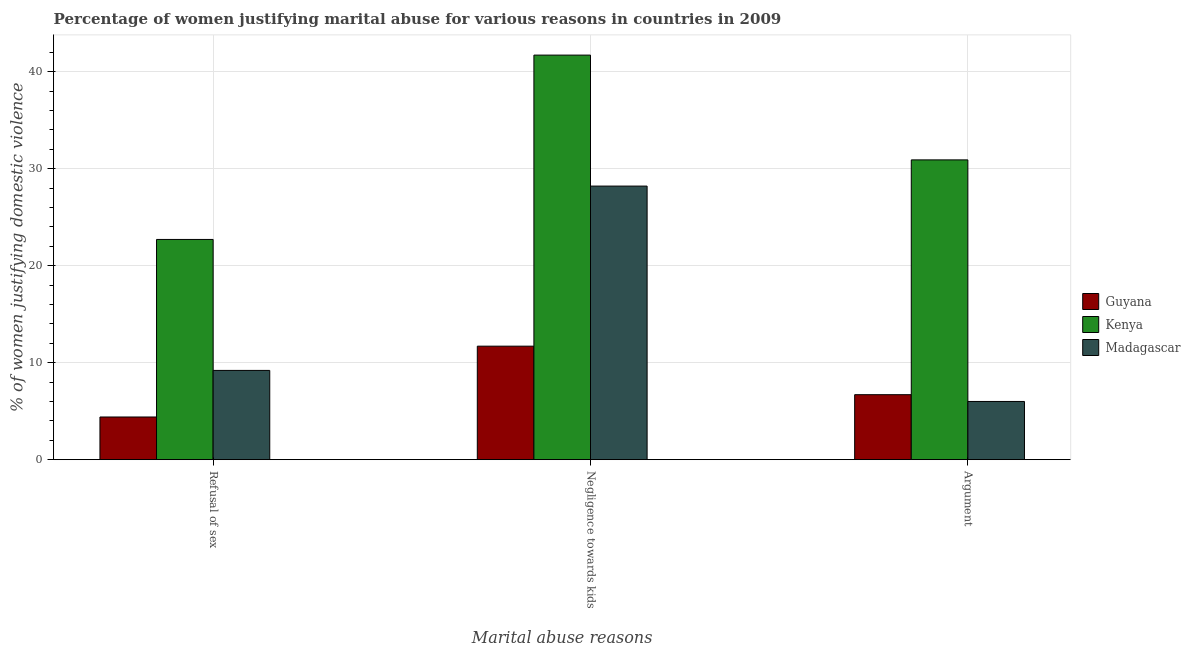How many groups of bars are there?
Offer a terse response. 3. How many bars are there on the 3rd tick from the right?
Make the answer very short. 3. What is the label of the 1st group of bars from the left?
Provide a succinct answer. Refusal of sex. Across all countries, what is the maximum percentage of women justifying domestic violence due to negligence towards kids?
Keep it short and to the point. 41.7. In which country was the percentage of women justifying domestic violence due to arguments maximum?
Provide a succinct answer. Kenya. In which country was the percentage of women justifying domestic violence due to arguments minimum?
Offer a terse response. Madagascar. What is the total percentage of women justifying domestic violence due to arguments in the graph?
Your answer should be compact. 43.6. What is the difference between the percentage of women justifying domestic violence due to negligence towards kids in Guyana and that in Madagascar?
Ensure brevity in your answer.  -16.5. What is the difference between the percentage of women justifying domestic violence due to arguments in Guyana and the percentage of women justifying domestic violence due to negligence towards kids in Kenya?
Offer a terse response. -35. What is the average percentage of women justifying domestic violence due to arguments per country?
Make the answer very short. 14.53. What is the difference between the percentage of women justifying domestic violence due to arguments and percentage of women justifying domestic violence due to negligence towards kids in Madagascar?
Offer a very short reply. -22.2. In how many countries, is the percentage of women justifying domestic violence due to arguments greater than 22 %?
Provide a succinct answer. 1. What is the ratio of the percentage of women justifying domestic violence due to arguments in Guyana to that in Kenya?
Give a very brief answer. 0.22. Is the percentage of women justifying domestic violence due to negligence towards kids in Guyana less than that in Madagascar?
Give a very brief answer. Yes. Is the difference between the percentage of women justifying domestic violence due to negligence towards kids in Guyana and Madagascar greater than the difference between the percentage of women justifying domestic violence due to arguments in Guyana and Madagascar?
Your response must be concise. No. What is the difference between the highest and the second highest percentage of women justifying domestic violence due to negligence towards kids?
Offer a terse response. 13.5. What is the difference between the highest and the lowest percentage of women justifying domestic violence due to negligence towards kids?
Your answer should be compact. 30. What does the 3rd bar from the left in Negligence towards kids represents?
Your answer should be compact. Madagascar. What does the 1st bar from the right in Argument represents?
Offer a terse response. Madagascar. Is it the case that in every country, the sum of the percentage of women justifying domestic violence due to refusal of sex and percentage of women justifying domestic violence due to negligence towards kids is greater than the percentage of women justifying domestic violence due to arguments?
Ensure brevity in your answer.  Yes. How many bars are there?
Make the answer very short. 9. Are all the bars in the graph horizontal?
Your response must be concise. No. What is the difference between two consecutive major ticks on the Y-axis?
Ensure brevity in your answer.  10. Are the values on the major ticks of Y-axis written in scientific E-notation?
Offer a very short reply. No. Does the graph contain any zero values?
Provide a short and direct response. No. Where does the legend appear in the graph?
Your answer should be compact. Center right. How are the legend labels stacked?
Offer a terse response. Vertical. What is the title of the graph?
Make the answer very short. Percentage of women justifying marital abuse for various reasons in countries in 2009. What is the label or title of the X-axis?
Provide a succinct answer. Marital abuse reasons. What is the label or title of the Y-axis?
Provide a short and direct response. % of women justifying domestic violence. What is the % of women justifying domestic violence of Guyana in Refusal of sex?
Make the answer very short. 4.4. What is the % of women justifying domestic violence of Kenya in Refusal of sex?
Provide a succinct answer. 22.7. What is the % of women justifying domestic violence in Kenya in Negligence towards kids?
Your response must be concise. 41.7. What is the % of women justifying domestic violence in Madagascar in Negligence towards kids?
Offer a terse response. 28.2. What is the % of women justifying domestic violence in Kenya in Argument?
Provide a succinct answer. 30.9. Across all Marital abuse reasons, what is the maximum % of women justifying domestic violence of Kenya?
Your response must be concise. 41.7. Across all Marital abuse reasons, what is the maximum % of women justifying domestic violence in Madagascar?
Your response must be concise. 28.2. Across all Marital abuse reasons, what is the minimum % of women justifying domestic violence of Kenya?
Offer a very short reply. 22.7. What is the total % of women justifying domestic violence in Guyana in the graph?
Your answer should be very brief. 22.8. What is the total % of women justifying domestic violence in Kenya in the graph?
Your response must be concise. 95.3. What is the total % of women justifying domestic violence of Madagascar in the graph?
Make the answer very short. 43.4. What is the difference between the % of women justifying domestic violence of Guyana in Refusal of sex and that in Negligence towards kids?
Offer a very short reply. -7.3. What is the difference between the % of women justifying domestic violence in Kenya in Refusal of sex and that in Negligence towards kids?
Make the answer very short. -19. What is the difference between the % of women justifying domestic violence of Guyana in Negligence towards kids and that in Argument?
Offer a terse response. 5. What is the difference between the % of women justifying domestic violence of Kenya in Negligence towards kids and that in Argument?
Offer a very short reply. 10.8. What is the difference between the % of women justifying domestic violence in Guyana in Refusal of sex and the % of women justifying domestic violence in Kenya in Negligence towards kids?
Offer a terse response. -37.3. What is the difference between the % of women justifying domestic violence in Guyana in Refusal of sex and the % of women justifying domestic violence in Madagascar in Negligence towards kids?
Make the answer very short. -23.8. What is the difference between the % of women justifying domestic violence in Kenya in Refusal of sex and the % of women justifying domestic violence in Madagascar in Negligence towards kids?
Offer a very short reply. -5.5. What is the difference between the % of women justifying domestic violence of Guyana in Refusal of sex and the % of women justifying domestic violence of Kenya in Argument?
Make the answer very short. -26.5. What is the difference between the % of women justifying domestic violence in Guyana in Refusal of sex and the % of women justifying domestic violence in Madagascar in Argument?
Give a very brief answer. -1.6. What is the difference between the % of women justifying domestic violence in Kenya in Refusal of sex and the % of women justifying domestic violence in Madagascar in Argument?
Provide a short and direct response. 16.7. What is the difference between the % of women justifying domestic violence in Guyana in Negligence towards kids and the % of women justifying domestic violence in Kenya in Argument?
Provide a short and direct response. -19.2. What is the difference between the % of women justifying domestic violence in Kenya in Negligence towards kids and the % of women justifying domestic violence in Madagascar in Argument?
Offer a terse response. 35.7. What is the average % of women justifying domestic violence in Guyana per Marital abuse reasons?
Provide a short and direct response. 7.6. What is the average % of women justifying domestic violence of Kenya per Marital abuse reasons?
Your answer should be compact. 31.77. What is the average % of women justifying domestic violence in Madagascar per Marital abuse reasons?
Make the answer very short. 14.47. What is the difference between the % of women justifying domestic violence of Guyana and % of women justifying domestic violence of Kenya in Refusal of sex?
Give a very brief answer. -18.3. What is the difference between the % of women justifying domestic violence of Guyana and % of women justifying domestic violence of Madagascar in Refusal of sex?
Give a very brief answer. -4.8. What is the difference between the % of women justifying domestic violence of Kenya and % of women justifying domestic violence of Madagascar in Refusal of sex?
Your answer should be compact. 13.5. What is the difference between the % of women justifying domestic violence in Guyana and % of women justifying domestic violence in Madagascar in Negligence towards kids?
Provide a succinct answer. -16.5. What is the difference between the % of women justifying domestic violence of Guyana and % of women justifying domestic violence of Kenya in Argument?
Provide a succinct answer. -24.2. What is the difference between the % of women justifying domestic violence in Guyana and % of women justifying domestic violence in Madagascar in Argument?
Keep it short and to the point. 0.7. What is the difference between the % of women justifying domestic violence in Kenya and % of women justifying domestic violence in Madagascar in Argument?
Make the answer very short. 24.9. What is the ratio of the % of women justifying domestic violence of Guyana in Refusal of sex to that in Negligence towards kids?
Your response must be concise. 0.38. What is the ratio of the % of women justifying domestic violence in Kenya in Refusal of sex to that in Negligence towards kids?
Your answer should be very brief. 0.54. What is the ratio of the % of women justifying domestic violence of Madagascar in Refusal of sex to that in Negligence towards kids?
Ensure brevity in your answer.  0.33. What is the ratio of the % of women justifying domestic violence in Guyana in Refusal of sex to that in Argument?
Your answer should be very brief. 0.66. What is the ratio of the % of women justifying domestic violence of Kenya in Refusal of sex to that in Argument?
Make the answer very short. 0.73. What is the ratio of the % of women justifying domestic violence of Madagascar in Refusal of sex to that in Argument?
Your answer should be compact. 1.53. What is the ratio of the % of women justifying domestic violence in Guyana in Negligence towards kids to that in Argument?
Provide a short and direct response. 1.75. What is the ratio of the % of women justifying domestic violence in Kenya in Negligence towards kids to that in Argument?
Keep it short and to the point. 1.35. What is the ratio of the % of women justifying domestic violence in Madagascar in Negligence towards kids to that in Argument?
Provide a short and direct response. 4.7. What is the difference between the highest and the second highest % of women justifying domestic violence of Guyana?
Offer a terse response. 5. What is the difference between the highest and the second highest % of women justifying domestic violence in Madagascar?
Your response must be concise. 19. 